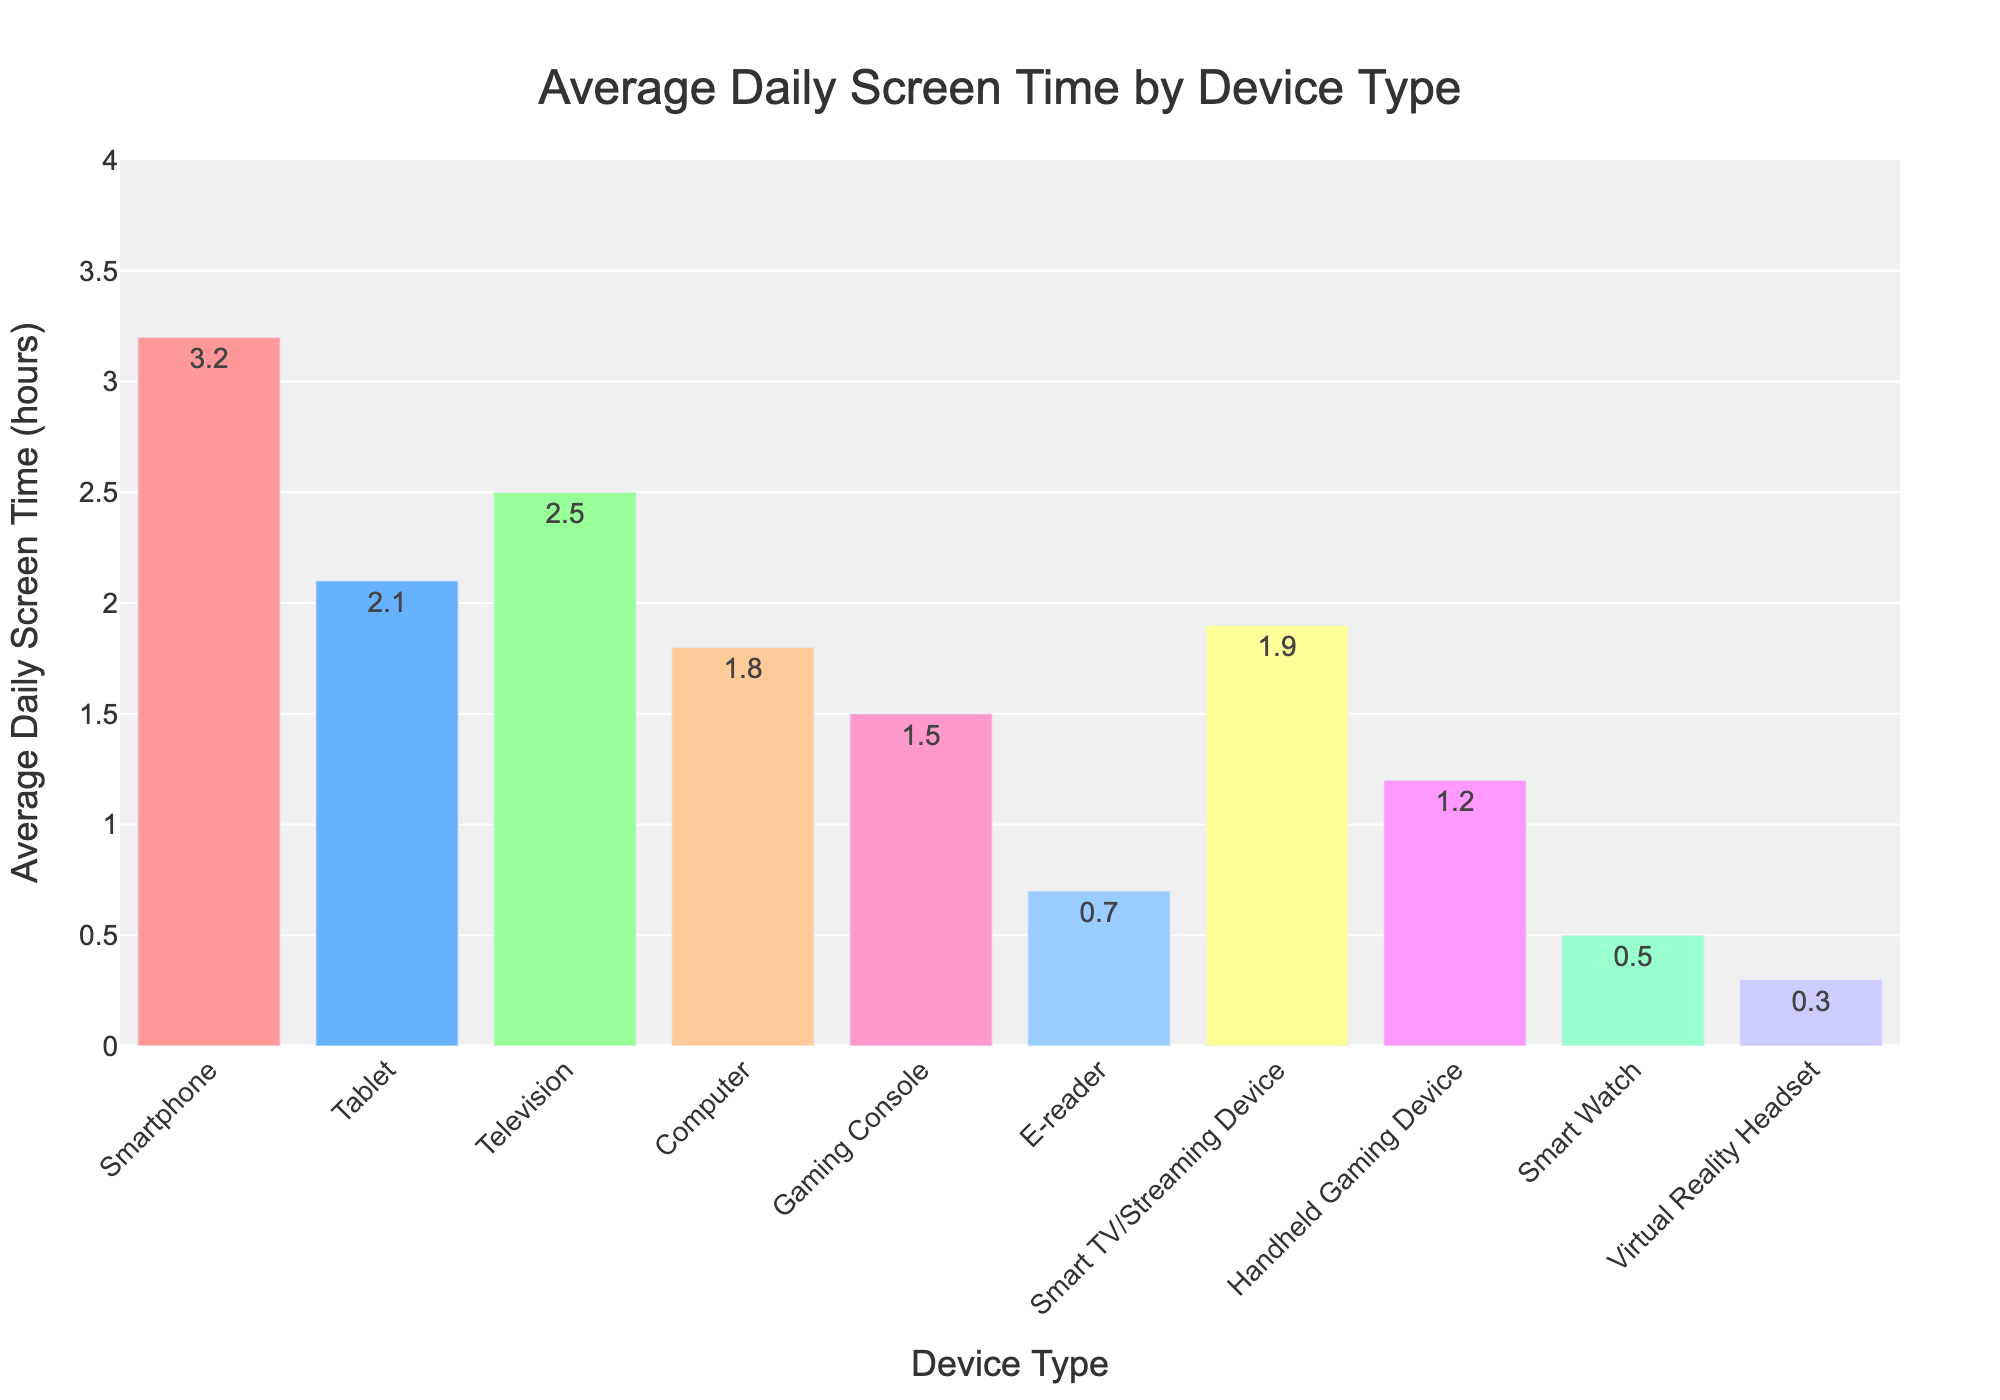Which device has the highest average daily screen time? The figure shows that the device with the highest average daily screen time has the tallest bar. The smartphone bar is the tallest.
Answer: Smartphone What is the difference in average daily screen time between the Tablet and the E-reader? To find the difference, subtract the lower value from the higher value: 2.1 (Tablet) - 0.7 (E-reader) = 1.4 hours.
Answer: 1.4 hours Which devices have a screen time of less than 1 hour? The bars representing devices with less than 1 hour of screen time are visually shorter. These include the E-reader, Smart Watch, and Virtual Reality Headset.
Answer: E-reader, Smart Watch, Virtual Reality Headset What is the combined average daily screen time for the Television and Computer? To find the combined screen time, add the values for Television and Computer: 2.5 (Television) + 1.8 (Computer) = 4.3 hours.
Answer: 4.3 hours Is the average daily screen time for Gaming Console greater than that for Handheld Gaming Device? By comparing the bar heights, the Gaming Console's bar is taller than the Handheld Gaming Device's bar.
Answer: Yes What percentage of the Smart Watch's screen time is the Gaming Console's screen time? To find the percentage, divide the screen time of the Gaming Console by the screen time of the Smart Watch and multiply by 100: (1.5 / 0.5) * 100 = 300%.
Answer: 300% Which device has the second-highest average daily screen time? By observing the bar heights, the second tallest bar corresponds to the Television, which has an average daily screen time of 2.5 hours.
Answer: Television What is the total average daily screen time for all devices combined? Add the screen times for all devices: 3.2 + 2.1 + 2.5 + 1.8 + 1.5 + 0.7 + 1.9 + 1.2 + 0.5 + 0.3 = 15.7 hours.
Answer: 15.7 hours Is the screen time of Smart TV/Streaming Device closer to the screen time of Tablet or Computer? Compare the values: Smart TV/Streaming Device (1.9), Tablet (2.1), Computer (1.8). The difference with Tablet is 0.2 (2.1 - 1.9), and the difference with Computer is 0.1 (1.9 - 1.8).
Answer: Computer 